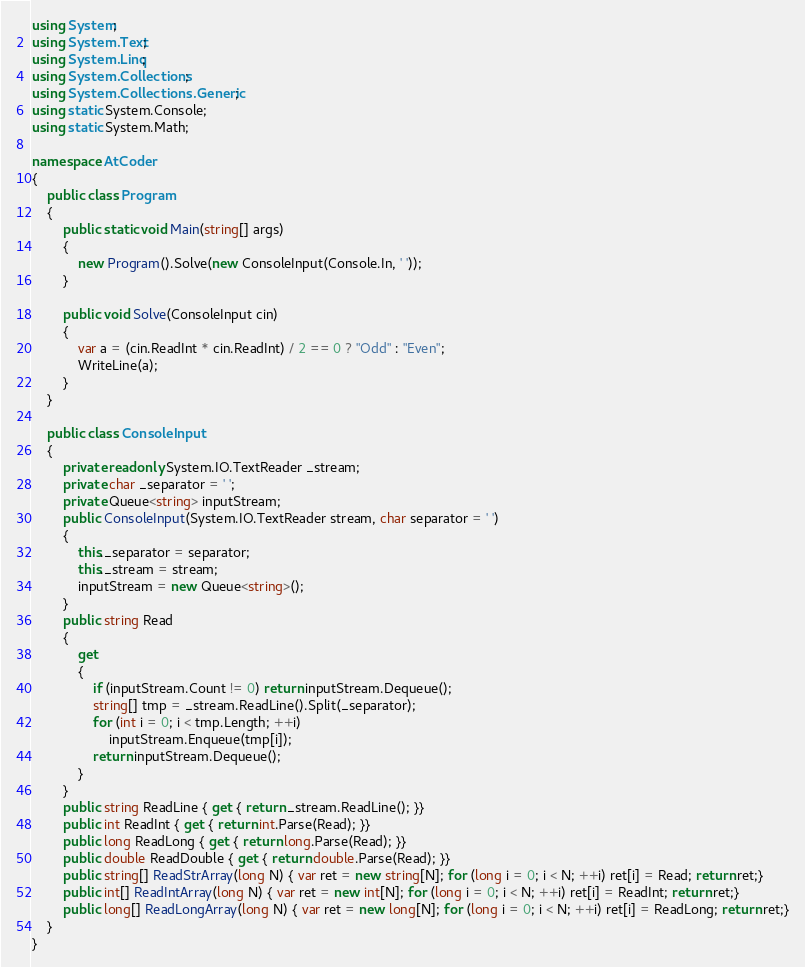<code> <loc_0><loc_0><loc_500><loc_500><_C#_>using System;
using System.Text;
using System.Linq;
using System.Collections;
using System.Collections.Generic;
using static System.Console;
using static System.Math;

namespace AtCoder
{
    public class Program
    {
        public static void Main(string[] args)
        {
            new Program().Solve(new ConsoleInput(Console.In, ' '));
        }

        public void Solve(ConsoleInput cin)
        {
            var a = (cin.ReadInt * cin.ReadInt) / 2 == 0 ? "Odd" : "Even";
            WriteLine(a);
        }
    }

    public class ConsoleInput
    {
        private readonly System.IO.TextReader _stream;
        private char _separator = ' ';
        private Queue<string> inputStream;
        public ConsoleInput(System.IO.TextReader stream, char separator = ' ')
        {
            this._separator = separator;
            this._stream = stream;
            inputStream = new Queue<string>();
        }
        public string Read
        {
            get
            {
                if (inputStream.Count != 0) return inputStream.Dequeue();
                string[] tmp = _stream.ReadLine().Split(_separator);
                for (int i = 0; i < tmp.Length; ++i)
                    inputStream.Enqueue(tmp[i]);
                return inputStream.Dequeue();
            }
        }
        public string ReadLine { get { return _stream.ReadLine(); }}
        public int ReadInt { get { return int.Parse(Read); }}
        public long ReadLong { get { return long.Parse(Read); }}
        public double ReadDouble { get { return double.Parse(Read); }}
        public string[] ReadStrArray(long N) { var ret = new string[N]; for (long i = 0; i < N; ++i) ret[i] = Read; return ret;}
        public int[] ReadIntArray(long N) { var ret = new int[N]; for (long i = 0; i < N; ++i) ret[i] = ReadInt; return ret;}
        public long[] ReadLongArray(long N) { var ret = new long[N]; for (long i = 0; i < N; ++i) ret[i] = ReadLong; return ret;}
    }
}
</code> 